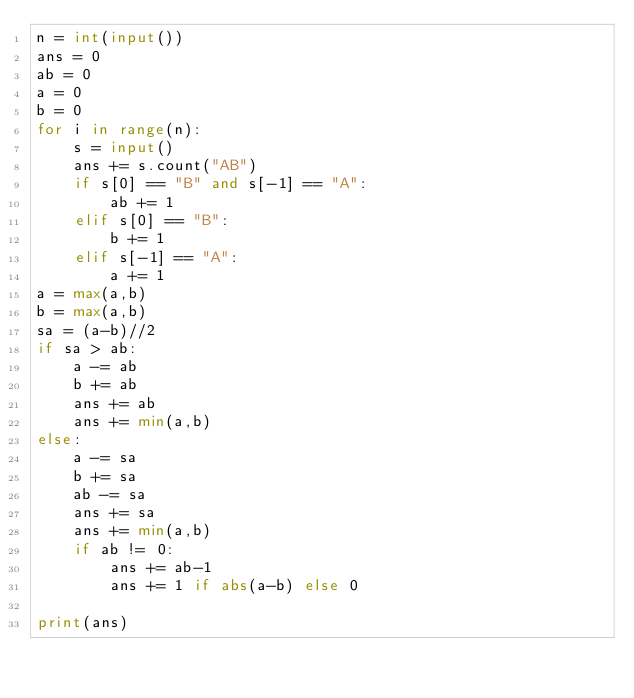Convert code to text. <code><loc_0><loc_0><loc_500><loc_500><_Python_>n = int(input())
ans = 0
ab = 0
a = 0
b = 0
for i in range(n):
    s = input()
    ans += s.count("AB")
    if s[0] == "B" and s[-1] == "A":
        ab += 1
    elif s[0] == "B":
        b += 1
    elif s[-1] == "A":
        a += 1
a = max(a,b)
b = max(a,b)
sa = (a-b)//2
if sa > ab:
    a -= ab
    b += ab
    ans += ab
    ans += min(a,b)
else:
    a -= sa
    b += sa
    ab -= sa
    ans += sa
    ans += min(a,b)
    if ab != 0:
        ans += ab-1
        ans += 1 if abs(a-b) else 0

print(ans)</code> 